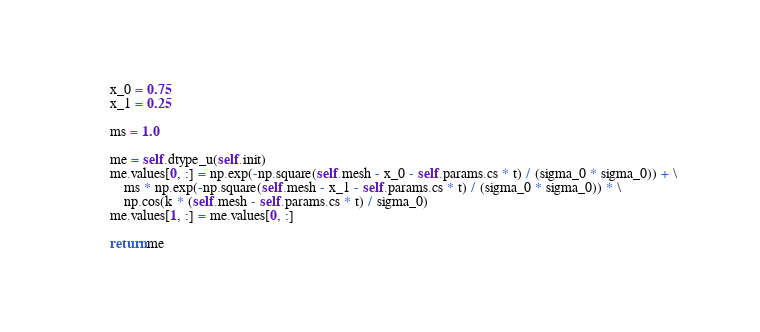<code> <loc_0><loc_0><loc_500><loc_500><_Python_>        x_0 = 0.75
        x_1 = 0.25

        ms = 1.0

        me = self.dtype_u(self.init)
        me.values[0, :] = np.exp(-np.square(self.mesh - x_0 - self.params.cs * t) / (sigma_0 * sigma_0)) + \
            ms * np.exp(-np.square(self.mesh - x_1 - self.params.cs * t) / (sigma_0 * sigma_0)) * \
            np.cos(k * (self.mesh - self.params.cs * t) / sigma_0)
        me.values[1, :] = me.values[0, :]

        return me
</code> 